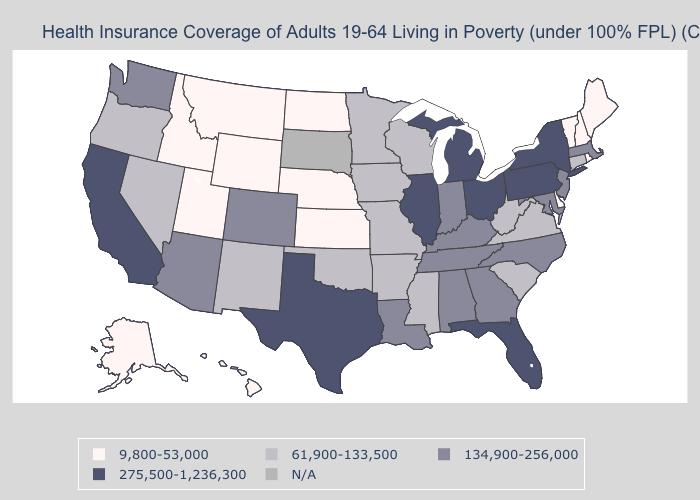What is the lowest value in states that border Utah?
Answer briefly. 9,800-53,000. What is the lowest value in the West?
Give a very brief answer. 9,800-53,000. What is the highest value in the USA?
Concise answer only. 275,500-1,236,300. Among the states that border Illinois , does Missouri have the lowest value?
Short answer required. Yes. What is the value of Connecticut?
Quick response, please. 61,900-133,500. How many symbols are there in the legend?
Give a very brief answer. 5. Does West Virginia have the highest value in the USA?
Be succinct. No. Name the states that have a value in the range N/A?
Short answer required. South Dakota. Does Minnesota have the lowest value in the MidWest?
Short answer required. No. Among the states that border Oregon , does Washington have the lowest value?
Concise answer only. No. What is the highest value in the Northeast ?
Answer briefly. 275,500-1,236,300. Which states have the lowest value in the MidWest?
Concise answer only. Kansas, Nebraska, North Dakota. Does the first symbol in the legend represent the smallest category?
Be succinct. Yes. Which states have the highest value in the USA?
Answer briefly. California, Florida, Illinois, Michigan, New York, Ohio, Pennsylvania, Texas. 